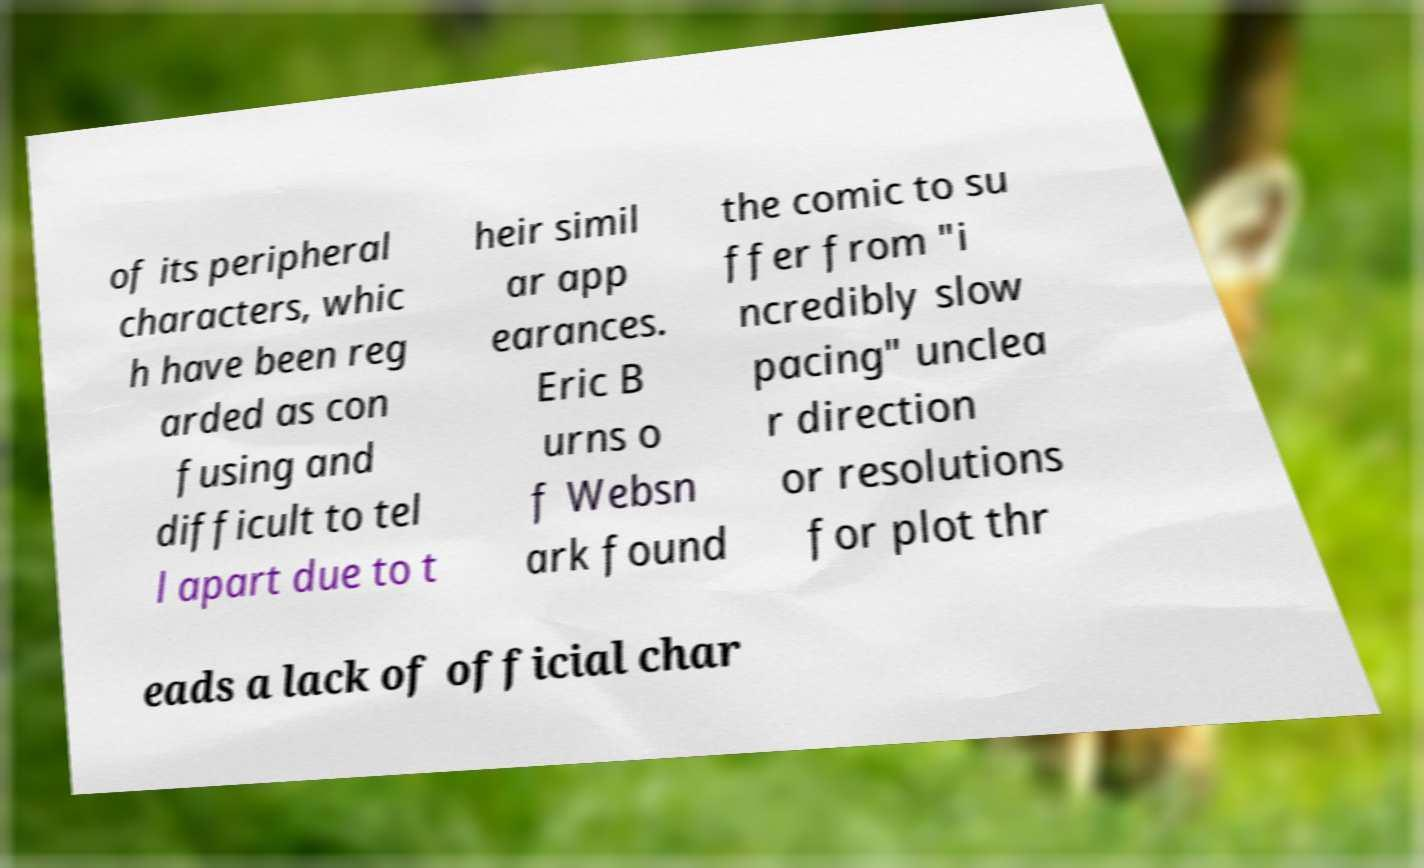Can you read and provide the text displayed in the image?This photo seems to have some interesting text. Can you extract and type it out for me? of its peripheral characters, whic h have been reg arded as con fusing and difficult to tel l apart due to t heir simil ar app earances. Eric B urns o f Websn ark found the comic to su ffer from "i ncredibly slow pacing" unclea r direction or resolutions for plot thr eads a lack of official char 